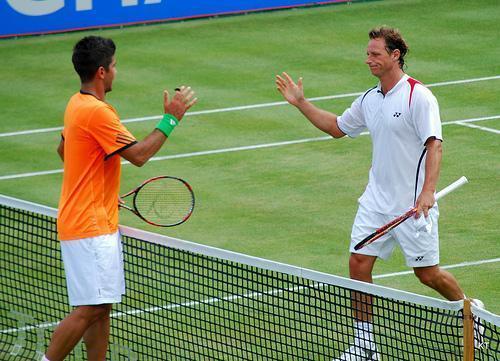How many people are there?
Give a very brief answer. 2. 